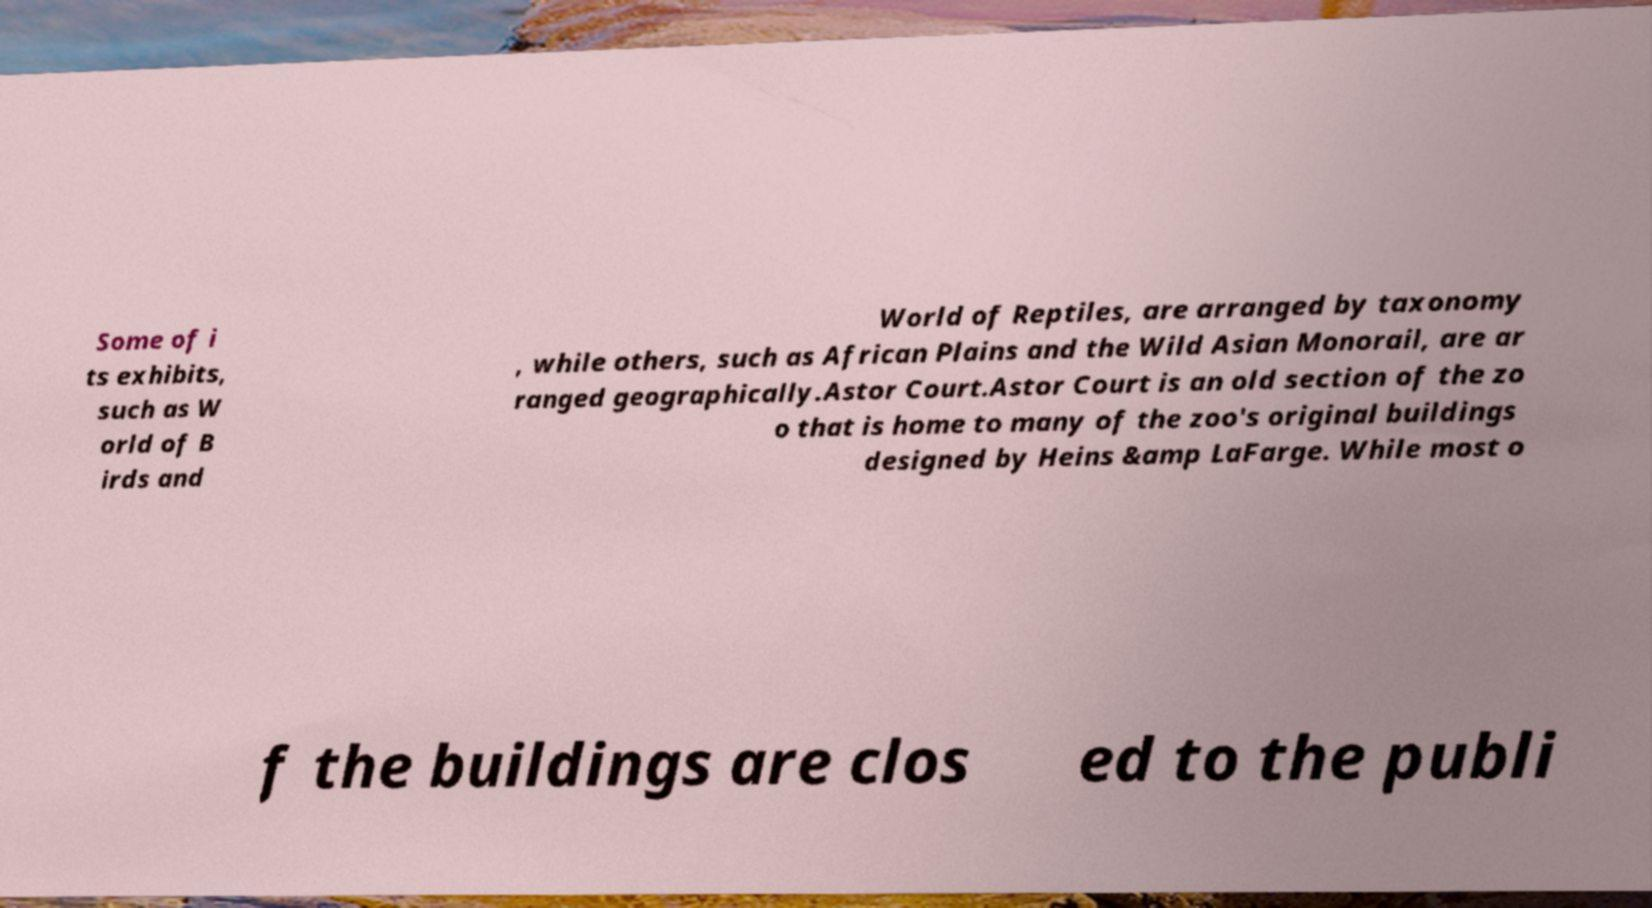Please read and relay the text visible in this image. What does it say? Some of i ts exhibits, such as W orld of B irds and World of Reptiles, are arranged by taxonomy , while others, such as African Plains and the Wild Asian Monorail, are ar ranged geographically.Astor Court.Astor Court is an old section of the zo o that is home to many of the zoo's original buildings designed by Heins &amp LaFarge. While most o f the buildings are clos ed to the publi 